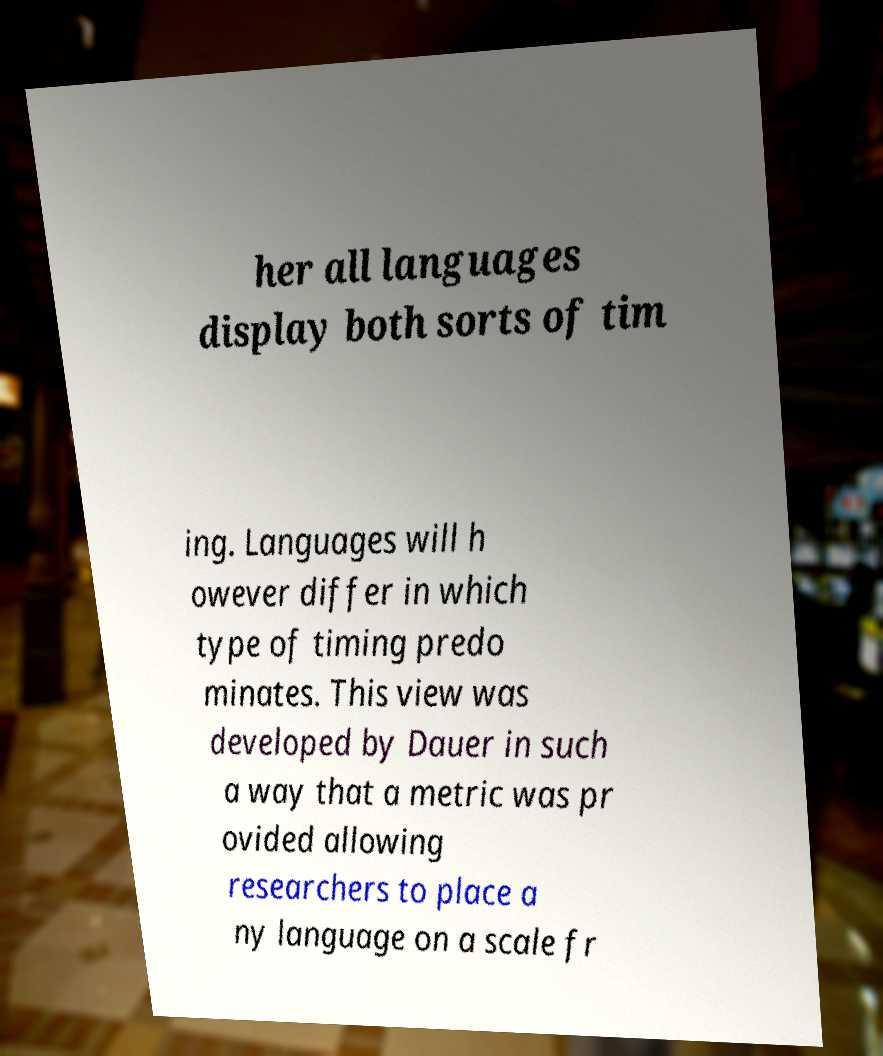I need the written content from this picture converted into text. Can you do that? her all languages display both sorts of tim ing. Languages will h owever differ in which type of timing predo minates. This view was developed by Dauer in such a way that a metric was pr ovided allowing researchers to place a ny language on a scale fr 